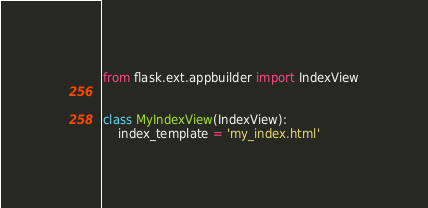Convert code to text. <code><loc_0><loc_0><loc_500><loc_500><_Python_>from flask.ext.appbuilder import IndexView


class MyIndexView(IndexView):
    index_template = 'my_index.html'
</code> 